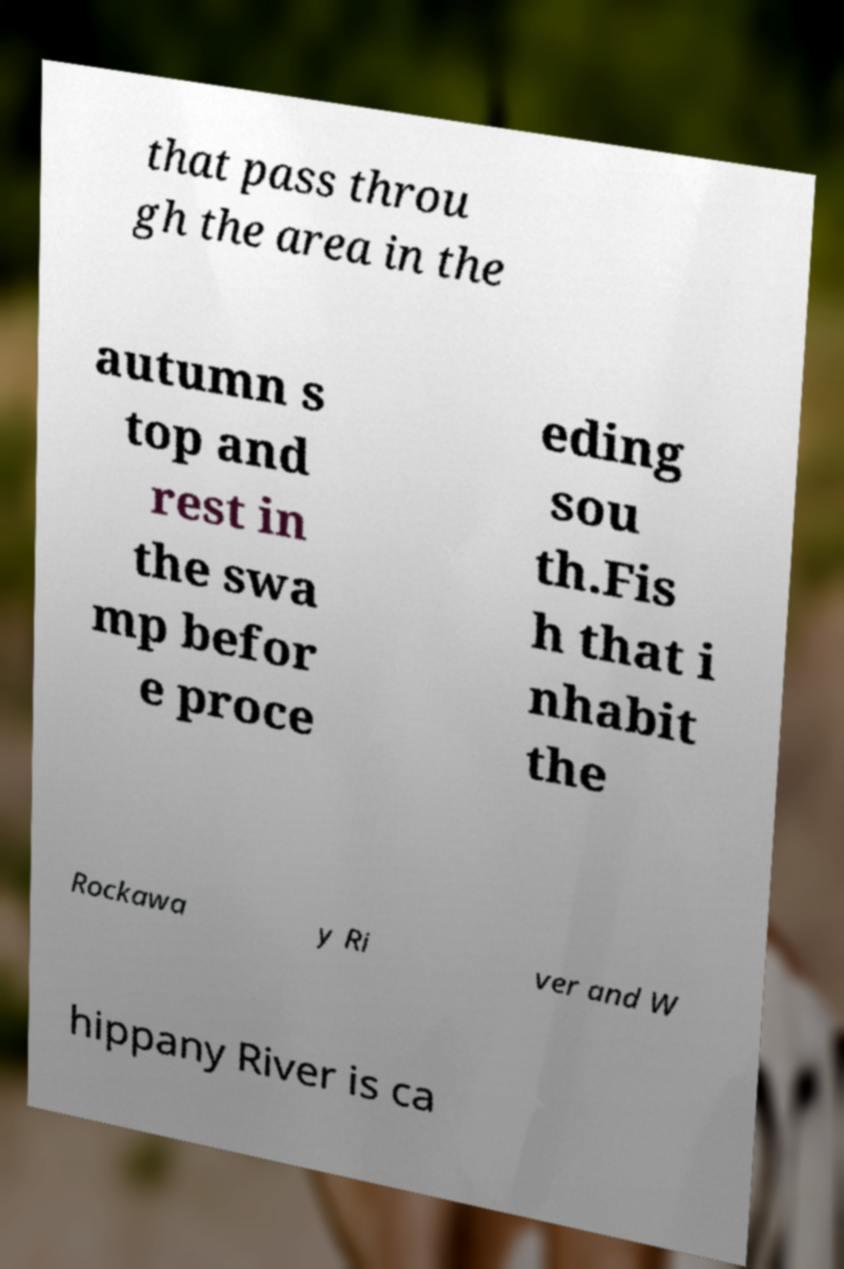Could you assist in decoding the text presented in this image and type it out clearly? that pass throu gh the area in the autumn s top and rest in the swa mp befor e proce eding sou th.Fis h that i nhabit the Rockawa y Ri ver and W hippany River is ca 